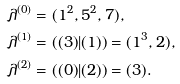Convert formula to latex. <formula><loc_0><loc_0><loc_500><loc_500>\lambda ^ { ( 0 ) } & = ( 1 ^ { 2 } , 5 ^ { 2 } , 7 ) , \\ \lambda ^ { ( 1 ) } & = ( ( 3 ) | ( 1 ) ) = ( 1 ^ { 3 } , 2 ) , \\ \lambda ^ { ( 2 ) } & = ( ( 0 ) | ( 2 ) ) = ( 3 ) .</formula> 